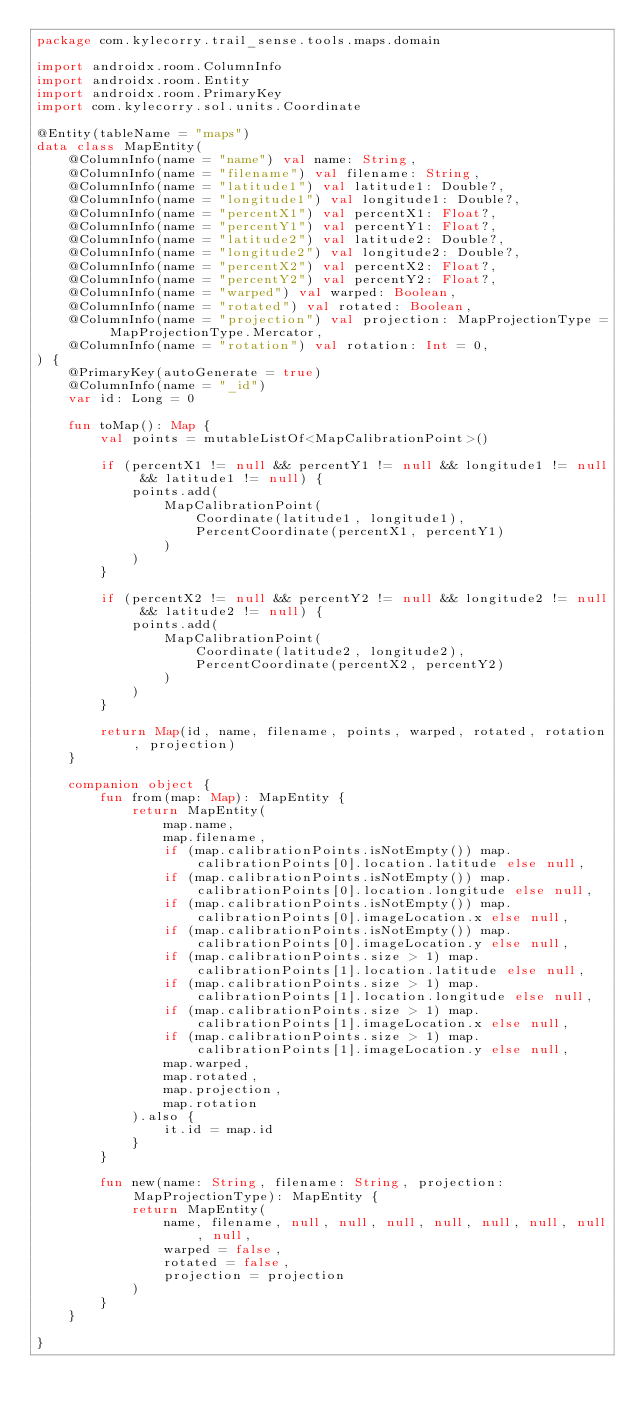Convert code to text. <code><loc_0><loc_0><loc_500><loc_500><_Kotlin_>package com.kylecorry.trail_sense.tools.maps.domain

import androidx.room.ColumnInfo
import androidx.room.Entity
import androidx.room.PrimaryKey
import com.kylecorry.sol.units.Coordinate

@Entity(tableName = "maps")
data class MapEntity(
    @ColumnInfo(name = "name") val name: String,
    @ColumnInfo(name = "filename") val filename: String,
    @ColumnInfo(name = "latitude1") val latitude1: Double?,
    @ColumnInfo(name = "longitude1") val longitude1: Double?,
    @ColumnInfo(name = "percentX1") val percentX1: Float?,
    @ColumnInfo(name = "percentY1") val percentY1: Float?,
    @ColumnInfo(name = "latitude2") val latitude2: Double?,
    @ColumnInfo(name = "longitude2") val longitude2: Double?,
    @ColumnInfo(name = "percentX2") val percentX2: Float?,
    @ColumnInfo(name = "percentY2") val percentY2: Float?,
    @ColumnInfo(name = "warped") val warped: Boolean,
    @ColumnInfo(name = "rotated") val rotated: Boolean,
    @ColumnInfo(name = "projection") val projection: MapProjectionType = MapProjectionType.Mercator,
    @ColumnInfo(name = "rotation") val rotation: Int = 0,
) {
    @PrimaryKey(autoGenerate = true)
    @ColumnInfo(name = "_id")
    var id: Long = 0

    fun toMap(): Map {
        val points = mutableListOf<MapCalibrationPoint>()

        if (percentX1 != null && percentY1 != null && longitude1 != null && latitude1 != null) {
            points.add(
                MapCalibrationPoint(
                    Coordinate(latitude1, longitude1),
                    PercentCoordinate(percentX1, percentY1)
                )
            )
        }

        if (percentX2 != null && percentY2 != null && longitude2 != null && latitude2 != null) {
            points.add(
                MapCalibrationPoint(
                    Coordinate(latitude2, longitude2),
                    PercentCoordinate(percentX2, percentY2)
                )
            )
        }

        return Map(id, name, filename, points, warped, rotated, rotation, projection)
    }

    companion object {
        fun from(map: Map): MapEntity {
            return MapEntity(
                map.name,
                map.filename,
                if (map.calibrationPoints.isNotEmpty()) map.calibrationPoints[0].location.latitude else null,
                if (map.calibrationPoints.isNotEmpty()) map.calibrationPoints[0].location.longitude else null,
                if (map.calibrationPoints.isNotEmpty()) map.calibrationPoints[0].imageLocation.x else null,
                if (map.calibrationPoints.isNotEmpty()) map.calibrationPoints[0].imageLocation.y else null,
                if (map.calibrationPoints.size > 1) map.calibrationPoints[1].location.latitude else null,
                if (map.calibrationPoints.size > 1) map.calibrationPoints[1].location.longitude else null,
                if (map.calibrationPoints.size > 1) map.calibrationPoints[1].imageLocation.x else null,
                if (map.calibrationPoints.size > 1) map.calibrationPoints[1].imageLocation.y else null,
                map.warped,
                map.rotated,
                map.projection,
                map.rotation
            ).also {
                it.id = map.id
            }
        }

        fun new(name: String, filename: String, projection: MapProjectionType): MapEntity {
            return MapEntity(
                name, filename, null, null, null, null, null, null, null, null,
                warped = false,
                rotated = false,
                projection = projection
            )
        }
    }

}
</code> 